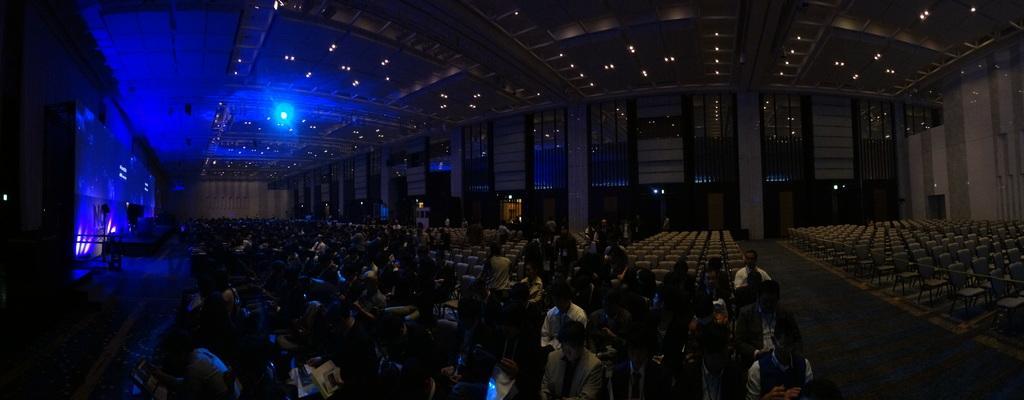In one or two sentences, can you explain what this image depicts? In this picture, we can see a few people, ground with chairs, and we can see vehicle in the background, wall with lights, and we can see stage with lights, speakers, and we can see the roof with lights and some objects attached to it. 